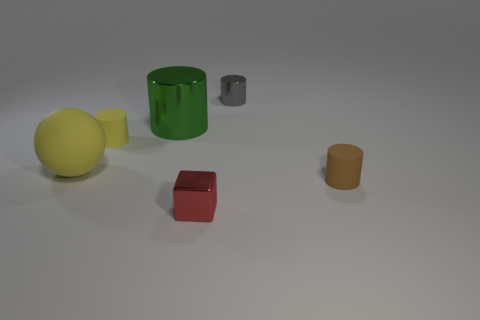Is there anything else that has the same color as the small metallic cylinder?
Your answer should be compact. No. What is the size of the object in front of the brown object?
Offer a very short reply. Small. What size is the metal cylinder on the right side of the shiny cylinder left of the tiny metal thing in front of the large yellow matte sphere?
Give a very brief answer. Small. There is a metallic object in front of the rubber cylinder right of the big green shiny cylinder; what color is it?
Make the answer very short. Red. There is a tiny gray object that is the same shape as the tiny yellow rubber object; what is its material?
Your response must be concise. Metal. There is a tiny yellow rubber cylinder; are there any matte things in front of it?
Offer a very short reply. Yes. How many big green objects are there?
Provide a short and direct response. 1. There is a tiny metallic object that is in front of the small brown matte thing; what number of big yellow matte balls are behind it?
Offer a very short reply. 1. There is a cube; does it have the same color as the small matte cylinder behind the matte sphere?
Your answer should be very brief. No. What number of large metal objects are the same shape as the brown rubber object?
Offer a terse response. 1. 